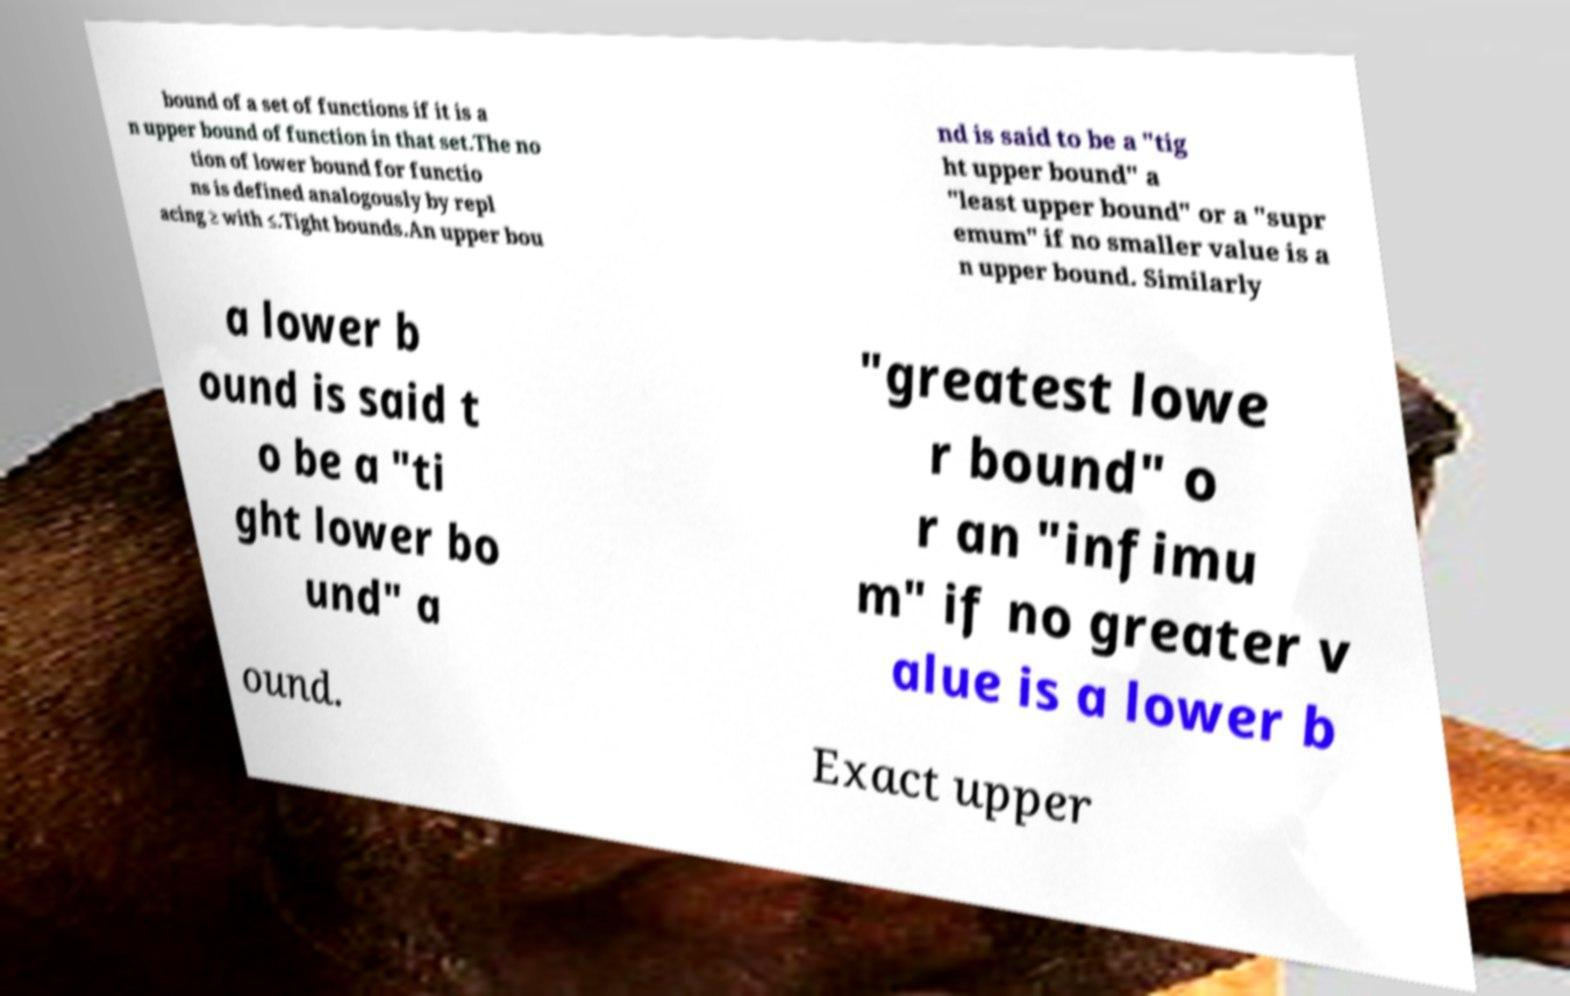There's text embedded in this image that I need extracted. Can you transcribe it verbatim? bound of a set of functions if it is a n upper bound of function in that set.The no tion of lower bound for functio ns is defined analogously by repl acing ≥ with ≤.Tight bounds.An upper bou nd is said to be a "tig ht upper bound" a "least upper bound" or a "supr emum" if no smaller value is a n upper bound. Similarly a lower b ound is said t o be a "ti ght lower bo und" a "greatest lowe r bound" o r an "infimu m" if no greater v alue is a lower b ound. Exact upper 